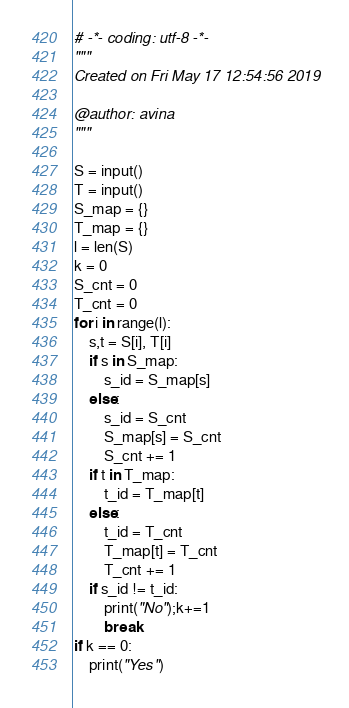Convert code to text. <code><loc_0><loc_0><loc_500><loc_500><_Python_># -*- coding: utf-8 -*-
"""
Created on Fri May 17 12:54:56 2019

@author: avina
"""

S = input()
T = input()
S_map = {}
T_map = {}
l = len(S)
k = 0
S_cnt = 0
T_cnt = 0
for i in range(l):
	s,t = S[i], T[i]
	if s in S_map:
		s_id = S_map[s]
	else:
		s_id = S_cnt
		S_map[s] = S_cnt
		S_cnt += 1
	if t in T_map:
		t_id = T_map[t]
	else:
		t_id = T_cnt
		T_map[t] = T_cnt
		T_cnt += 1
	if s_id != t_id:
		print("No");k+=1
		break
if k == 0:
    print("Yes")</code> 